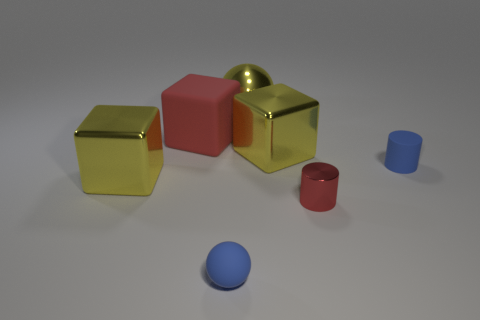Add 1 small things. How many objects exist? 8 Subtract all yellow blocks. How many blocks are left? 1 Subtract all red cubes. How many cubes are left? 2 Subtract 2 cubes. How many cubes are left? 1 Subtract all blocks. How many objects are left? 4 Subtract all brown balls. Subtract all green cylinders. How many balls are left? 2 Subtract all cyan cubes. How many red cylinders are left? 1 Add 6 small blue rubber objects. How many small blue rubber objects are left? 8 Add 6 green metallic balls. How many green metallic balls exist? 6 Subtract 0 cyan cylinders. How many objects are left? 7 